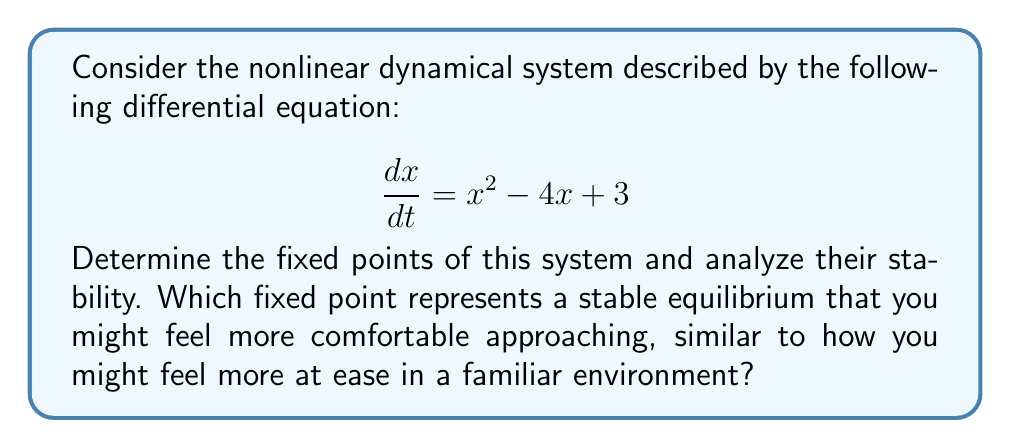Can you answer this question? 1. Find the fixed points:
   Set $\frac{dx}{dt} = 0$ and solve for $x$:
   $$x^2 - 4x + 3 = 0$$
   $$(x - 1)(x - 3) = 0$$
   Thus, the fixed points are $x_1 = 1$ and $x_2 = 3$.

2. Analyze stability:
   Calculate the derivative of $f(x) = x^2 - 4x + 3$:
   $$f'(x) = 2x - 4$$

3. Evaluate $f'(x)$ at each fixed point:
   At $x_1 = 1$: $f'(1) = 2(1) - 4 = -2$
   At $x_2 = 3$: $f'(3) = 2(3) - 4 = 2$

4. Interpret results:
   - For $x_1 = 1$, $f'(1) < 0$, so this is a stable fixed point.
   - For $x_2 = 3$, $f'(3) > 0$, so this is an unstable fixed point.

5. Relating to the persona:
   The stable fixed point at $x_1 = 1$ represents a comfortable equilibrium, similar to a familiar environment where you might feel more at ease. As you approach this point, the system naturally tends towards it, much like how you might gravitate towards familiar situations.
Answer: $x_1 = 1$ (stable), $x_2 = 3$ (unstable) 